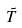Convert formula to latex. <formula><loc_0><loc_0><loc_500><loc_500>\tilde { T }</formula> 